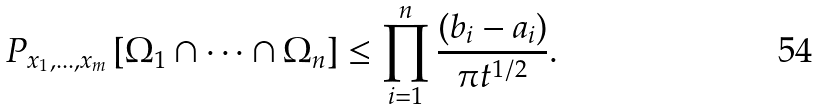<formula> <loc_0><loc_0><loc_500><loc_500>P _ { x _ { 1 } , \dots , x _ { m } } \left [ \Omega _ { 1 } \cap \dots \cap \Omega _ { n } \right ] \leq \prod _ { i = 1 } ^ { n } \frac { ( b _ { i } - a _ { i } ) } { \pi t ^ { 1 / 2 } } .</formula> 